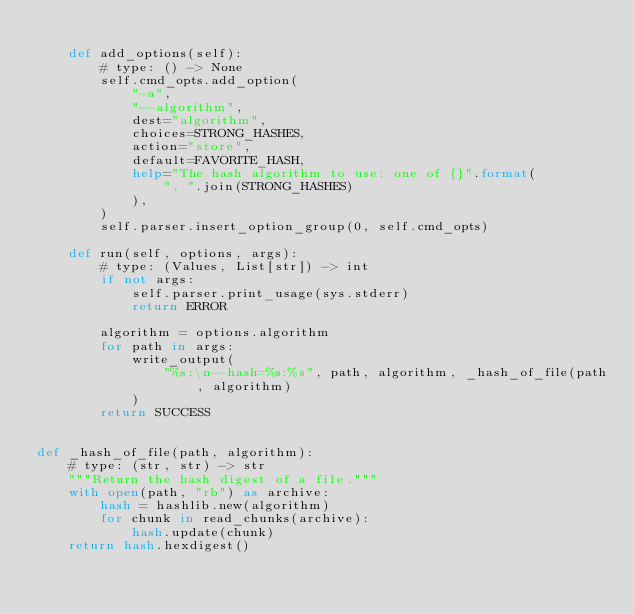Convert code to text. <code><loc_0><loc_0><loc_500><loc_500><_Python_>
    def add_options(self):
        # type: () -> None
        self.cmd_opts.add_option(
            "-a",
            "--algorithm",
            dest="algorithm",
            choices=STRONG_HASHES,
            action="store",
            default=FAVORITE_HASH,
            help="The hash algorithm to use: one of {}".format(
                ", ".join(STRONG_HASHES)
            ),
        )
        self.parser.insert_option_group(0, self.cmd_opts)

    def run(self, options, args):
        # type: (Values, List[str]) -> int
        if not args:
            self.parser.print_usage(sys.stderr)
            return ERROR

        algorithm = options.algorithm
        for path in args:
            write_output(
                "%s:\n--hash=%s:%s", path, algorithm, _hash_of_file(path, algorithm)
            )
        return SUCCESS


def _hash_of_file(path, algorithm):
    # type: (str, str) -> str
    """Return the hash digest of a file."""
    with open(path, "rb") as archive:
        hash = hashlib.new(algorithm)
        for chunk in read_chunks(archive):
            hash.update(chunk)
    return hash.hexdigest()
</code> 